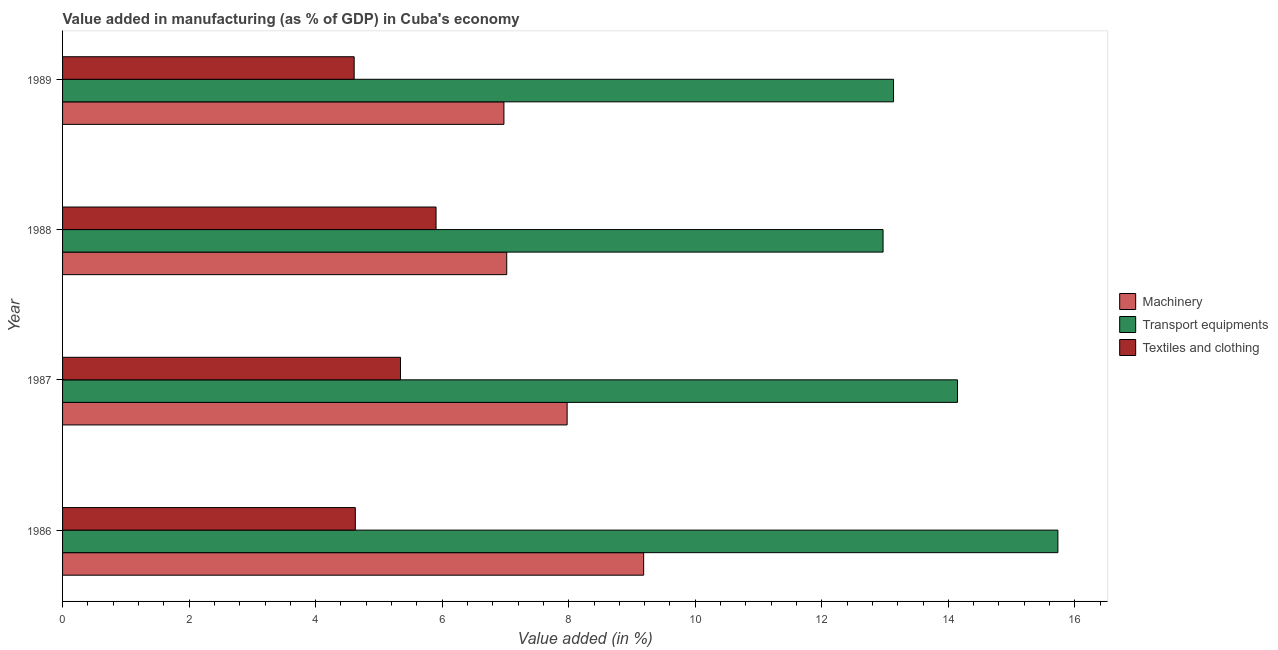How many groups of bars are there?
Give a very brief answer. 4. Are the number of bars per tick equal to the number of legend labels?
Offer a very short reply. Yes. Are the number of bars on each tick of the Y-axis equal?
Keep it short and to the point. Yes. What is the value added in manufacturing textile and clothing in 1986?
Ensure brevity in your answer.  4.63. Across all years, what is the maximum value added in manufacturing textile and clothing?
Provide a succinct answer. 5.9. Across all years, what is the minimum value added in manufacturing machinery?
Your answer should be compact. 6.98. In which year was the value added in manufacturing machinery maximum?
Your answer should be very brief. 1986. In which year was the value added in manufacturing textile and clothing minimum?
Offer a terse response. 1989. What is the total value added in manufacturing transport equipments in the graph?
Provide a succinct answer. 55.98. What is the difference between the value added in manufacturing textile and clothing in 1986 and that in 1989?
Offer a very short reply. 0.02. What is the difference between the value added in manufacturing transport equipments in 1987 and the value added in manufacturing machinery in 1986?
Make the answer very short. 4.96. What is the average value added in manufacturing textile and clothing per year?
Your answer should be very brief. 5.12. In the year 1986, what is the difference between the value added in manufacturing machinery and value added in manufacturing textile and clothing?
Your answer should be compact. 4.56. In how many years, is the value added in manufacturing textile and clothing greater than 12.8 %?
Your answer should be compact. 0. Is the difference between the value added in manufacturing machinery in 1986 and 1987 greater than the difference between the value added in manufacturing transport equipments in 1986 and 1987?
Give a very brief answer. No. What is the difference between the highest and the second highest value added in manufacturing transport equipments?
Provide a short and direct response. 1.59. What is the difference between the highest and the lowest value added in manufacturing machinery?
Provide a succinct answer. 2.21. What does the 2nd bar from the top in 1989 represents?
Provide a short and direct response. Transport equipments. What does the 2nd bar from the bottom in 1986 represents?
Your answer should be very brief. Transport equipments. Is it the case that in every year, the sum of the value added in manufacturing machinery and value added in manufacturing transport equipments is greater than the value added in manufacturing textile and clothing?
Give a very brief answer. Yes. How many bars are there?
Your answer should be very brief. 12. Are all the bars in the graph horizontal?
Your response must be concise. Yes. Are the values on the major ticks of X-axis written in scientific E-notation?
Keep it short and to the point. No. Does the graph contain any zero values?
Offer a very short reply. No. How are the legend labels stacked?
Keep it short and to the point. Vertical. What is the title of the graph?
Your answer should be very brief. Value added in manufacturing (as % of GDP) in Cuba's economy. Does "Argument" appear as one of the legend labels in the graph?
Ensure brevity in your answer.  No. What is the label or title of the X-axis?
Your answer should be very brief. Value added (in %). What is the Value added (in %) of Machinery in 1986?
Give a very brief answer. 9.18. What is the Value added (in %) of Transport equipments in 1986?
Offer a terse response. 15.73. What is the Value added (in %) of Textiles and clothing in 1986?
Ensure brevity in your answer.  4.63. What is the Value added (in %) of Machinery in 1987?
Provide a succinct answer. 7.97. What is the Value added (in %) in Transport equipments in 1987?
Ensure brevity in your answer.  14.15. What is the Value added (in %) in Textiles and clothing in 1987?
Ensure brevity in your answer.  5.34. What is the Value added (in %) in Machinery in 1988?
Keep it short and to the point. 7.02. What is the Value added (in %) of Transport equipments in 1988?
Offer a terse response. 12.97. What is the Value added (in %) in Textiles and clothing in 1988?
Make the answer very short. 5.9. What is the Value added (in %) in Machinery in 1989?
Make the answer very short. 6.98. What is the Value added (in %) in Transport equipments in 1989?
Keep it short and to the point. 13.13. What is the Value added (in %) in Textiles and clothing in 1989?
Your answer should be very brief. 4.61. Across all years, what is the maximum Value added (in %) of Machinery?
Ensure brevity in your answer.  9.18. Across all years, what is the maximum Value added (in %) in Transport equipments?
Your response must be concise. 15.73. Across all years, what is the maximum Value added (in %) of Textiles and clothing?
Your response must be concise. 5.9. Across all years, what is the minimum Value added (in %) of Machinery?
Your response must be concise. 6.98. Across all years, what is the minimum Value added (in %) in Transport equipments?
Ensure brevity in your answer.  12.97. Across all years, what is the minimum Value added (in %) in Textiles and clothing?
Ensure brevity in your answer.  4.61. What is the total Value added (in %) of Machinery in the graph?
Ensure brevity in your answer.  31.16. What is the total Value added (in %) of Transport equipments in the graph?
Offer a terse response. 55.98. What is the total Value added (in %) of Textiles and clothing in the graph?
Keep it short and to the point. 20.48. What is the difference between the Value added (in %) of Machinery in 1986 and that in 1987?
Your response must be concise. 1.21. What is the difference between the Value added (in %) of Transport equipments in 1986 and that in 1987?
Make the answer very short. 1.59. What is the difference between the Value added (in %) of Textiles and clothing in 1986 and that in 1987?
Ensure brevity in your answer.  -0.71. What is the difference between the Value added (in %) of Machinery in 1986 and that in 1988?
Ensure brevity in your answer.  2.16. What is the difference between the Value added (in %) of Transport equipments in 1986 and that in 1988?
Your answer should be compact. 2.76. What is the difference between the Value added (in %) of Textiles and clothing in 1986 and that in 1988?
Keep it short and to the point. -1.28. What is the difference between the Value added (in %) in Machinery in 1986 and that in 1989?
Provide a short and direct response. 2.21. What is the difference between the Value added (in %) in Transport equipments in 1986 and that in 1989?
Give a very brief answer. 2.6. What is the difference between the Value added (in %) in Textiles and clothing in 1986 and that in 1989?
Provide a short and direct response. 0.02. What is the difference between the Value added (in %) in Machinery in 1987 and that in 1988?
Provide a short and direct response. 0.95. What is the difference between the Value added (in %) of Transport equipments in 1987 and that in 1988?
Offer a terse response. 1.18. What is the difference between the Value added (in %) in Textiles and clothing in 1987 and that in 1988?
Your answer should be very brief. -0.56. What is the difference between the Value added (in %) of Transport equipments in 1987 and that in 1989?
Provide a succinct answer. 1.01. What is the difference between the Value added (in %) in Textiles and clothing in 1987 and that in 1989?
Your answer should be very brief. 0.73. What is the difference between the Value added (in %) of Machinery in 1988 and that in 1989?
Your answer should be very brief. 0.04. What is the difference between the Value added (in %) in Transport equipments in 1988 and that in 1989?
Ensure brevity in your answer.  -0.17. What is the difference between the Value added (in %) in Textiles and clothing in 1988 and that in 1989?
Provide a short and direct response. 1.29. What is the difference between the Value added (in %) of Machinery in 1986 and the Value added (in %) of Transport equipments in 1987?
Ensure brevity in your answer.  -4.96. What is the difference between the Value added (in %) in Machinery in 1986 and the Value added (in %) in Textiles and clothing in 1987?
Keep it short and to the point. 3.84. What is the difference between the Value added (in %) in Transport equipments in 1986 and the Value added (in %) in Textiles and clothing in 1987?
Give a very brief answer. 10.39. What is the difference between the Value added (in %) in Machinery in 1986 and the Value added (in %) in Transport equipments in 1988?
Provide a short and direct response. -3.78. What is the difference between the Value added (in %) of Machinery in 1986 and the Value added (in %) of Textiles and clothing in 1988?
Your answer should be very brief. 3.28. What is the difference between the Value added (in %) in Transport equipments in 1986 and the Value added (in %) in Textiles and clothing in 1988?
Offer a terse response. 9.83. What is the difference between the Value added (in %) in Machinery in 1986 and the Value added (in %) in Transport equipments in 1989?
Your response must be concise. -3.95. What is the difference between the Value added (in %) of Machinery in 1986 and the Value added (in %) of Textiles and clothing in 1989?
Offer a terse response. 4.58. What is the difference between the Value added (in %) of Transport equipments in 1986 and the Value added (in %) of Textiles and clothing in 1989?
Your answer should be very brief. 11.12. What is the difference between the Value added (in %) of Machinery in 1987 and the Value added (in %) of Transport equipments in 1988?
Offer a very short reply. -4.99. What is the difference between the Value added (in %) in Machinery in 1987 and the Value added (in %) in Textiles and clothing in 1988?
Offer a terse response. 2.07. What is the difference between the Value added (in %) in Transport equipments in 1987 and the Value added (in %) in Textiles and clothing in 1988?
Ensure brevity in your answer.  8.24. What is the difference between the Value added (in %) in Machinery in 1987 and the Value added (in %) in Transport equipments in 1989?
Ensure brevity in your answer.  -5.16. What is the difference between the Value added (in %) of Machinery in 1987 and the Value added (in %) of Textiles and clothing in 1989?
Provide a succinct answer. 3.37. What is the difference between the Value added (in %) of Transport equipments in 1987 and the Value added (in %) of Textiles and clothing in 1989?
Provide a short and direct response. 9.54. What is the difference between the Value added (in %) in Machinery in 1988 and the Value added (in %) in Transport equipments in 1989?
Provide a short and direct response. -6.11. What is the difference between the Value added (in %) of Machinery in 1988 and the Value added (in %) of Textiles and clothing in 1989?
Provide a succinct answer. 2.41. What is the difference between the Value added (in %) of Transport equipments in 1988 and the Value added (in %) of Textiles and clothing in 1989?
Make the answer very short. 8.36. What is the average Value added (in %) in Machinery per year?
Offer a terse response. 7.79. What is the average Value added (in %) of Transport equipments per year?
Offer a very short reply. 13.99. What is the average Value added (in %) in Textiles and clothing per year?
Offer a terse response. 5.12. In the year 1986, what is the difference between the Value added (in %) in Machinery and Value added (in %) in Transport equipments?
Your answer should be very brief. -6.55. In the year 1986, what is the difference between the Value added (in %) of Machinery and Value added (in %) of Textiles and clothing?
Keep it short and to the point. 4.56. In the year 1986, what is the difference between the Value added (in %) of Transport equipments and Value added (in %) of Textiles and clothing?
Offer a terse response. 11.1. In the year 1987, what is the difference between the Value added (in %) of Machinery and Value added (in %) of Transport equipments?
Keep it short and to the point. -6.17. In the year 1987, what is the difference between the Value added (in %) in Machinery and Value added (in %) in Textiles and clothing?
Offer a terse response. 2.63. In the year 1987, what is the difference between the Value added (in %) of Transport equipments and Value added (in %) of Textiles and clothing?
Ensure brevity in your answer.  8.8. In the year 1988, what is the difference between the Value added (in %) in Machinery and Value added (in %) in Transport equipments?
Provide a succinct answer. -5.95. In the year 1988, what is the difference between the Value added (in %) in Machinery and Value added (in %) in Textiles and clothing?
Provide a succinct answer. 1.12. In the year 1988, what is the difference between the Value added (in %) of Transport equipments and Value added (in %) of Textiles and clothing?
Make the answer very short. 7.07. In the year 1989, what is the difference between the Value added (in %) of Machinery and Value added (in %) of Transport equipments?
Your response must be concise. -6.16. In the year 1989, what is the difference between the Value added (in %) of Machinery and Value added (in %) of Textiles and clothing?
Keep it short and to the point. 2.37. In the year 1989, what is the difference between the Value added (in %) of Transport equipments and Value added (in %) of Textiles and clothing?
Provide a succinct answer. 8.53. What is the ratio of the Value added (in %) in Machinery in 1986 to that in 1987?
Your answer should be very brief. 1.15. What is the ratio of the Value added (in %) in Transport equipments in 1986 to that in 1987?
Offer a very short reply. 1.11. What is the ratio of the Value added (in %) in Textiles and clothing in 1986 to that in 1987?
Make the answer very short. 0.87. What is the ratio of the Value added (in %) of Machinery in 1986 to that in 1988?
Ensure brevity in your answer.  1.31. What is the ratio of the Value added (in %) of Transport equipments in 1986 to that in 1988?
Your answer should be compact. 1.21. What is the ratio of the Value added (in %) in Textiles and clothing in 1986 to that in 1988?
Offer a terse response. 0.78. What is the ratio of the Value added (in %) of Machinery in 1986 to that in 1989?
Provide a succinct answer. 1.32. What is the ratio of the Value added (in %) in Transport equipments in 1986 to that in 1989?
Provide a short and direct response. 1.2. What is the ratio of the Value added (in %) in Machinery in 1987 to that in 1988?
Your answer should be compact. 1.14. What is the ratio of the Value added (in %) in Transport equipments in 1987 to that in 1988?
Make the answer very short. 1.09. What is the ratio of the Value added (in %) in Textiles and clothing in 1987 to that in 1988?
Make the answer very short. 0.9. What is the ratio of the Value added (in %) in Machinery in 1987 to that in 1989?
Make the answer very short. 1.14. What is the ratio of the Value added (in %) in Transport equipments in 1987 to that in 1989?
Give a very brief answer. 1.08. What is the ratio of the Value added (in %) of Textiles and clothing in 1987 to that in 1989?
Ensure brevity in your answer.  1.16. What is the ratio of the Value added (in %) in Machinery in 1988 to that in 1989?
Offer a very short reply. 1.01. What is the ratio of the Value added (in %) in Transport equipments in 1988 to that in 1989?
Your response must be concise. 0.99. What is the ratio of the Value added (in %) of Textiles and clothing in 1988 to that in 1989?
Your answer should be very brief. 1.28. What is the difference between the highest and the second highest Value added (in %) in Machinery?
Keep it short and to the point. 1.21. What is the difference between the highest and the second highest Value added (in %) in Transport equipments?
Your answer should be compact. 1.59. What is the difference between the highest and the second highest Value added (in %) in Textiles and clothing?
Your response must be concise. 0.56. What is the difference between the highest and the lowest Value added (in %) in Machinery?
Your answer should be compact. 2.21. What is the difference between the highest and the lowest Value added (in %) of Transport equipments?
Provide a succinct answer. 2.76. What is the difference between the highest and the lowest Value added (in %) in Textiles and clothing?
Provide a succinct answer. 1.29. 